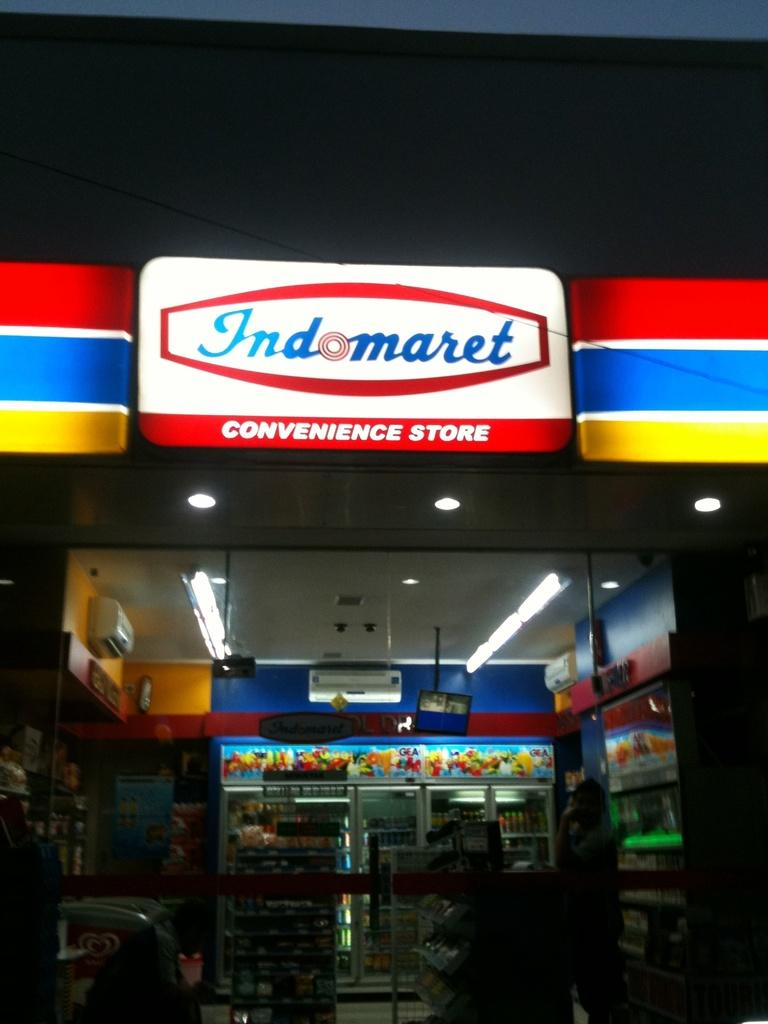What type of establishment is depicted in the image? There is a store in the image. Can you describe any text that is visible in the image? There is text on the top of the image. What type of cart can be seen in the image? There is no cart present in the image. What place does the store represent in terms of harmony? The image does not provide information about the store's representation of harmony, as it only shows the store and text. 